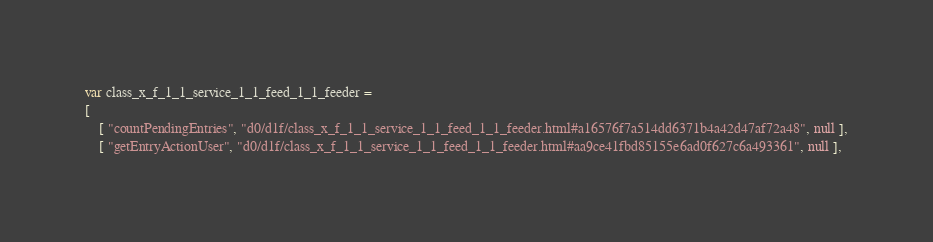Convert code to text. <code><loc_0><loc_0><loc_500><loc_500><_JavaScript_>var class_x_f_1_1_service_1_1_feed_1_1_feeder =
[
    [ "countPendingEntries", "d0/d1f/class_x_f_1_1_service_1_1_feed_1_1_feeder.html#a16576f7a514dd6371b4a42d47af72a48", null ],
    [ "getEntryActionUser", "d0/d1f/class_x_f_1_1_service_1_1_feed_1_1_feeder.html#aa9ce41fbd85155e6ad0f627c6a493361", null ],</code> 